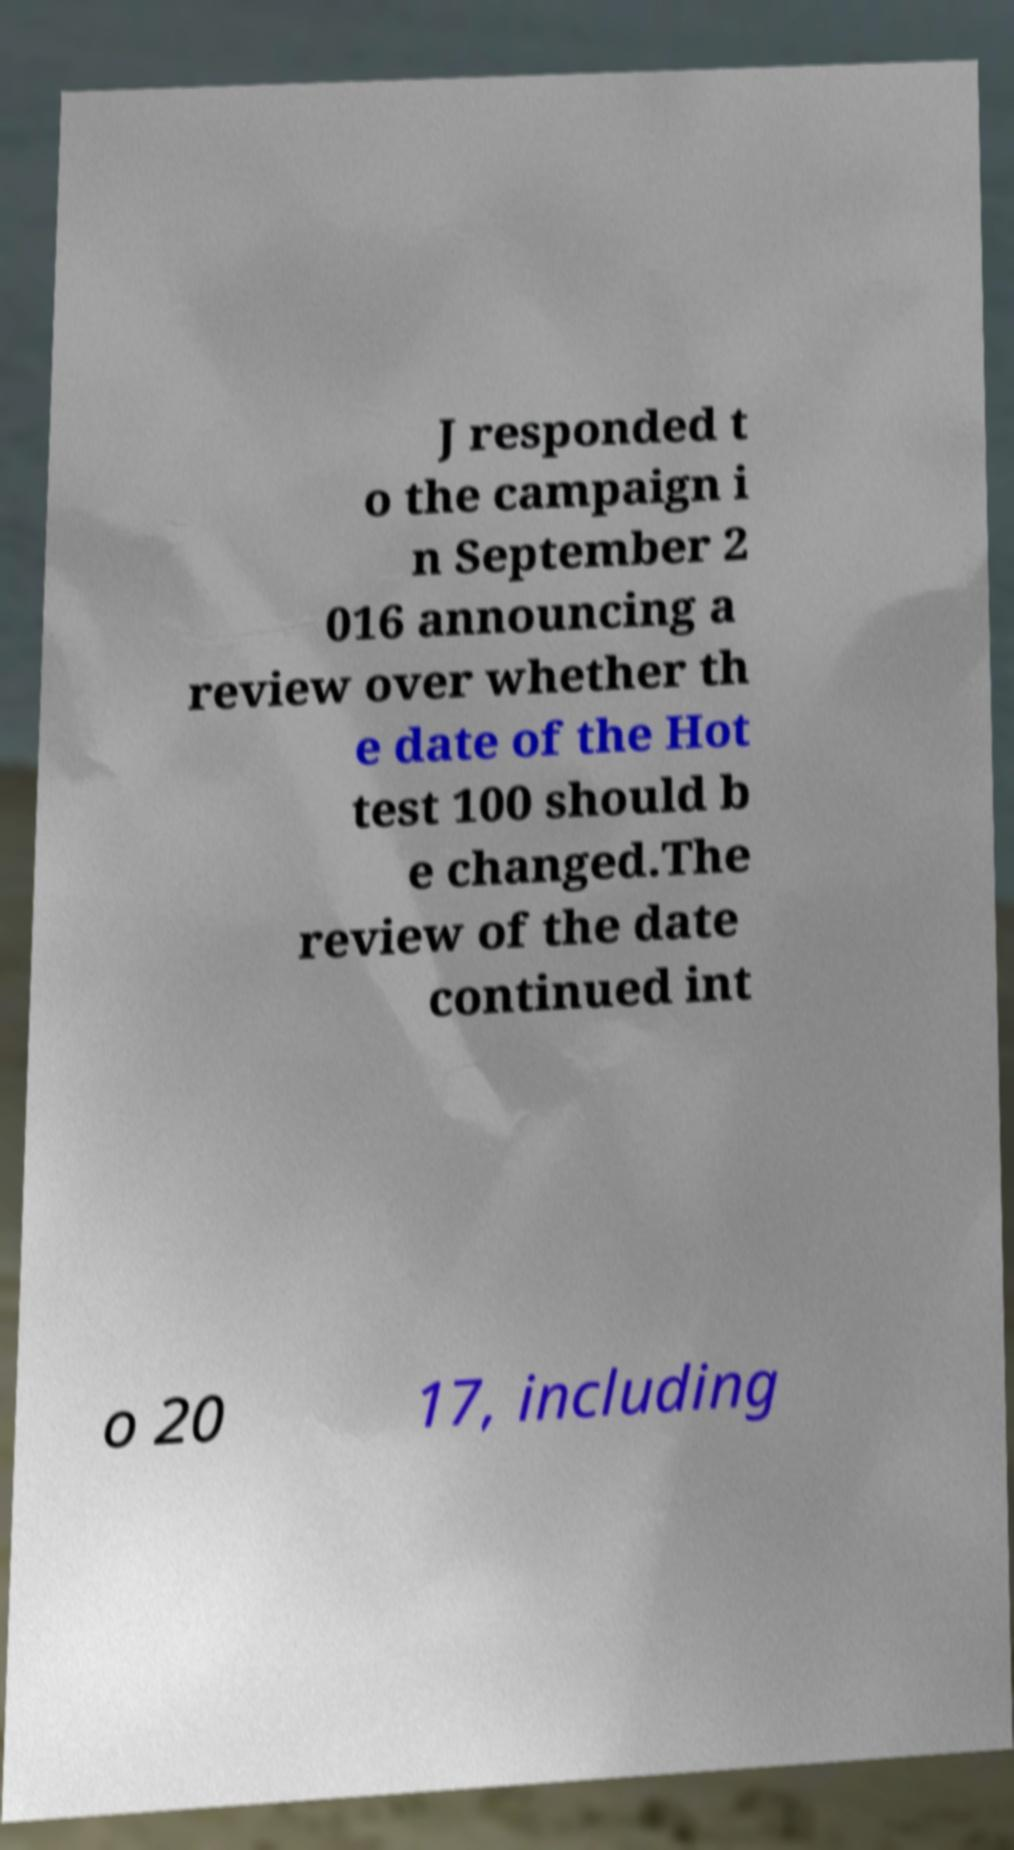Could you extract and type out the text from this image? J responded t o the campaign i n September 2 016 announcing a review over whether th e date of the Hot test 100 should b e changed.The review of the date continued int o 20 17, including 